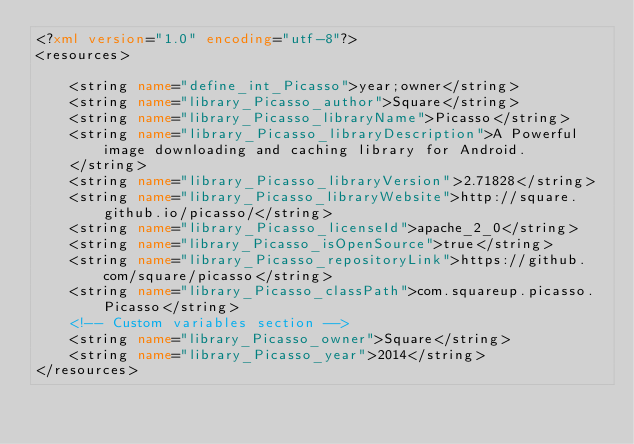<code> <loc_0><loc_0><loc_500><loc_500><_XML_><?xml version="1.0" encoding="utf-8"?>
<resources>

    <string name="define_int_Picasso">year;owner</string>
    <string name="library_Picasso_author">Square</string>
    <string name="library_Picasso_libraryName">Picasso</string>
    <string name="library_Picasso_libraryDescription">A Powerful image downloading and caching library for Android.
    </string>
    <string name="library_Picasso_libraryVersion">2.71828</string>
    <string name="library_Picasso_libraryWebsite">http://square.github.io/picasso/</string>
    <string name="library_Picasso_licenseId">apache_2_0</string>
    <string name="library_Picasso_isOpenSource">true</string>
    <string name="library_Picasso_repositoryLink">https://github.com/square/picasso</string>
    <string name="library_Picasso_classPath">com.squareup.picasso.Picasso</string>
    <!-- Custom variables section -->
    <string name="library_Picasso_owner">Square</string>
    <string name="library_Picasso_year">2014</string>
</resources>
</code> 